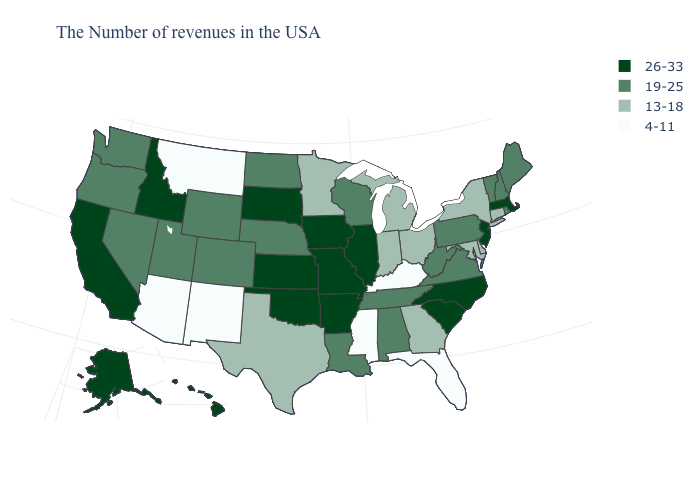What is the value of Maine?
Be succinct. 19-25. What is the value of Arkansas?
Be succinct. 26-33. Which states have the lowest value in the South?
Answer briefly. Florida, Kentucky, Mississippi. Among the states that border North Carolina , does Georgia have the lowest value?
Concise answer only. Yes. How many symbols are there in the legend?
Keep it brief. 4. What is the value of Mississippi?
Quick response, please. 4-11. How many symbols are there in the legend?
Answer briefly. 4. What is the highest value in the West ?
Short answer required. 26-33. Name the states that have a value in the range 4-11?
Short answer required. Florida, Kentucky, Mississippi, New Mexico, Montana, Arizona. How many symbols are there in the legend?
Keep it brief. 4. Among the states that border Nebraska , which have the highest value?
Answer briefly. Missouri, Iowa, Kansas, South Dakota. Among the states that border Washington , which have the highest value?
Be succinct. Idaho. Which states have the lowest value in the USA?
Give a very brief answer. Florida, Kentucky, Mississippi, New Mexico, Montana, Arizona. Is the legend a continuous bar?
Short answer required. No. Is the legend a continuous bar?
Be succinct. No. 